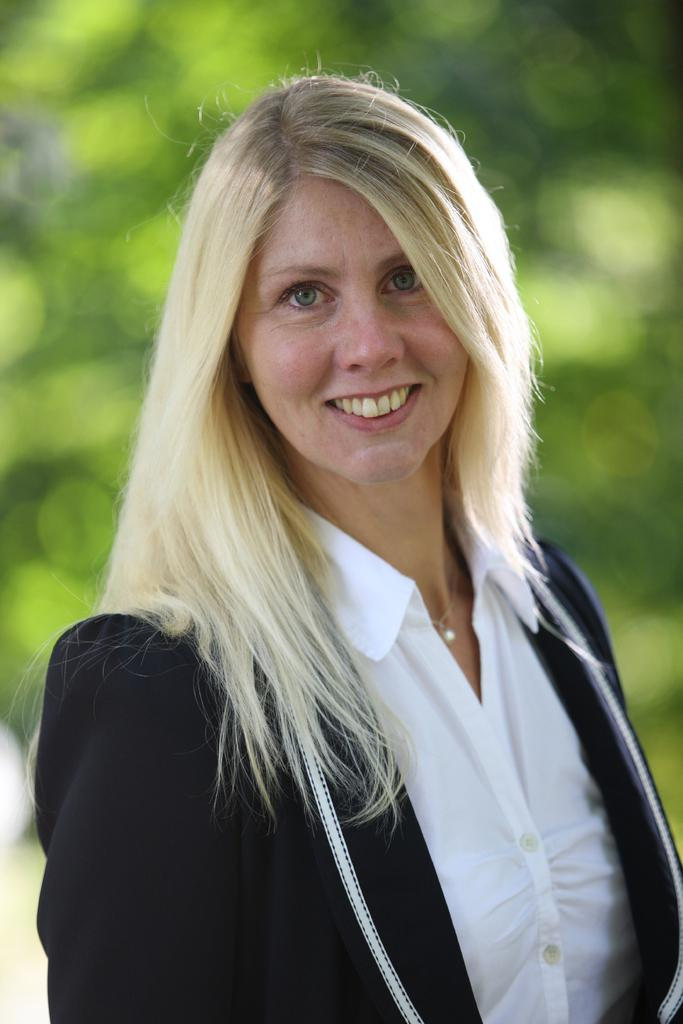Who is present in the image? There is a woman in the image. What is the woman's facial expression? The woman is smiling. Can you describe the background of the image? The background of the image is blurred. What design is featured on the letter the woman is holding in the image? There is no letter present in the image, so it is not possible to determine the design on any letter. 